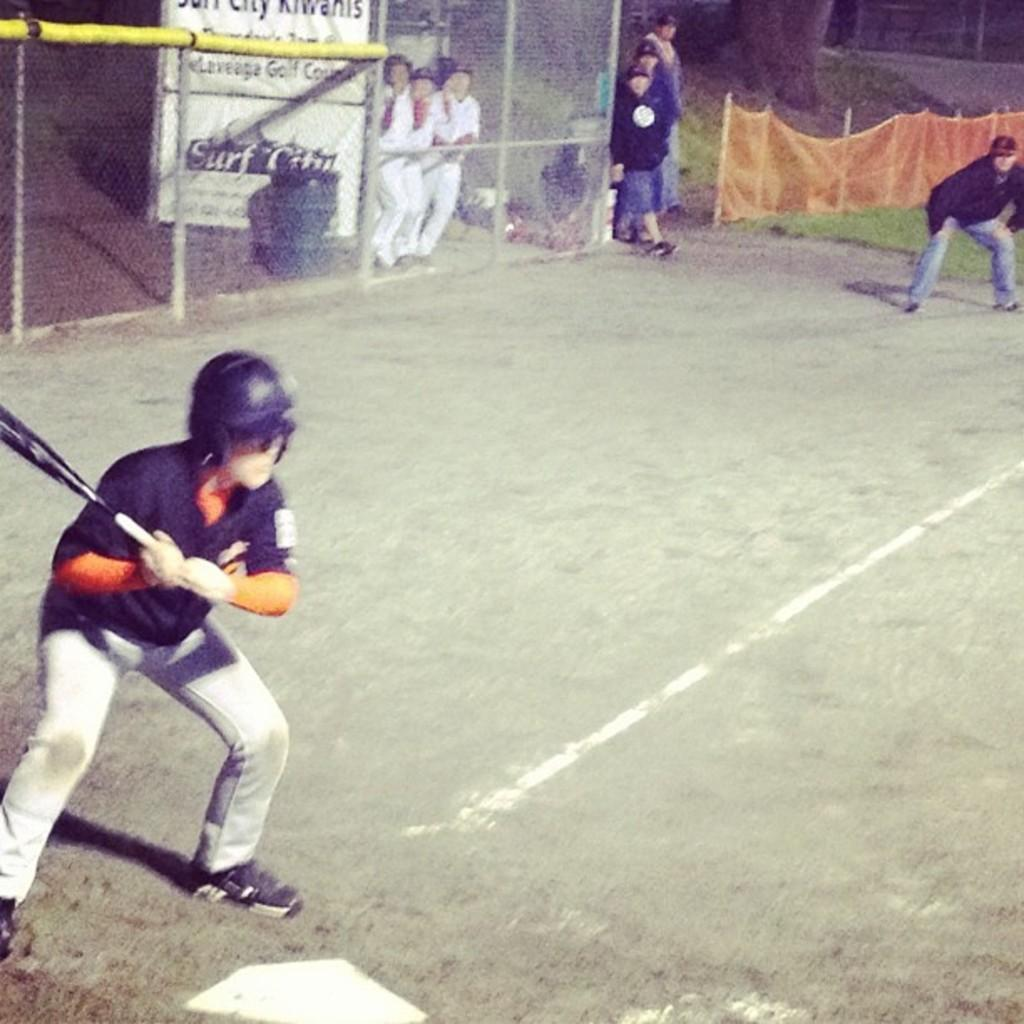<image>
Summarize the visual content of the image. A sign for "Surf Camp" sits behind a metal fence near baseball players 